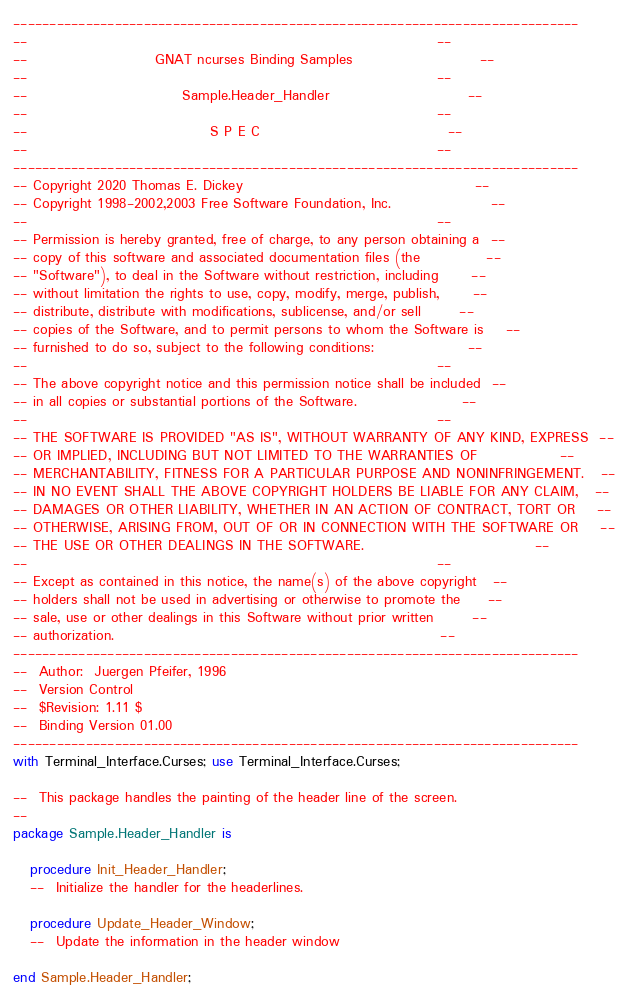Convert code to text. <code><loc_0><loc_0><loc_500><loc_500><_Ada_>------------------------------------------------------------------------------
--                                                                          --
--                       GNAT ncurses Binding Samples                       --
--                                                                          --
--                            Sample.Header_Handler                         --
--                                                                          --
--                                 S P E C                                  --
--                                                                          --
------------------------------------------------------------------------------
-- Copyright 2020 Thomas E. Dickey                                          --
-- Copyright 1998-2002,2003 Free Software Foundation, Inc.                  --
--                                                                          --
-- Permission is hereby granted, free of charge, to any person obtaining a  --
-- copy of this software and associated documentation files (the            --
-- "Software"), to deal in the Software without restriction, including      --
-- without limitation the rights to use, copy, modify, merge, publish,      --
-- distribute, distribute with modifications, sublicense, and/or sell       --
-- copies of the Software, and to permit persons to whom the Software is    --
-- furnished to do so, subject to the following conditions:                 --
--                                                                          --
-- The above copyright notice and this permission notice shall be included  --
-- in all copies or substantial portions of the Software.                   --
--                                                                          --
-- THE SOFTWARE IS PROVIDED "AS IS", WITHOUT WARRANTY OF ANY KIND, EXPRESS  --
-- OR IMPLIED, INCLUDING BUT NOT LIMITED TO THE WARRANTIES OF               --
-- MERCHANTABILITY, FITNESS FOR A PARTICULAR PURPOSE AND NONINFRINGEMENT.   --
-- IN NO EVENT SHALL THE ABOVE COPYRIGHT HOLDERS BE LIABLE FOR ANY CLAIM,   --
-- DAMAGES OR OTHER LIABILITY, WHETHER IN AN ACTION OF CONTRACT, TORT OR    --
-- OTHERWISE, ARISING FROM, OUT OF OR IN CONNECTION WITH THE SOFTWARE OR    --
-- THE USE OR OTHER DEALINGS IN THE SOFTWARE.                               --
--                                                                          --
-- Except as contained in this notice, the name(s) of the above copyright   --
-- holders shall not be used in advertising or otherwise to promote the     --
-- sale, use or other dealings in this Software without prior written       --
-- authorization.                                                           --
------------------------------------------------------------------------------
--  Author:  Juergen Pfeifer, 1996
--  Version Control
--  $Revision: 1.11 $
--  Binding Version 01.00
------------------------------------------------------------------------------
with Terminal_Interface.Curses; use Terminal_Interface.Curses;

--  This package handles the painting of the header line of the screen.
--
package Sample.Header_Handler is

   procedure Init_Header_Handler;
   --  Initialize the handler for the headerlines.

   procedure Update_Header_Window;
   --  Update the information in the header window

end Sample.Header_Handler;
</code> 